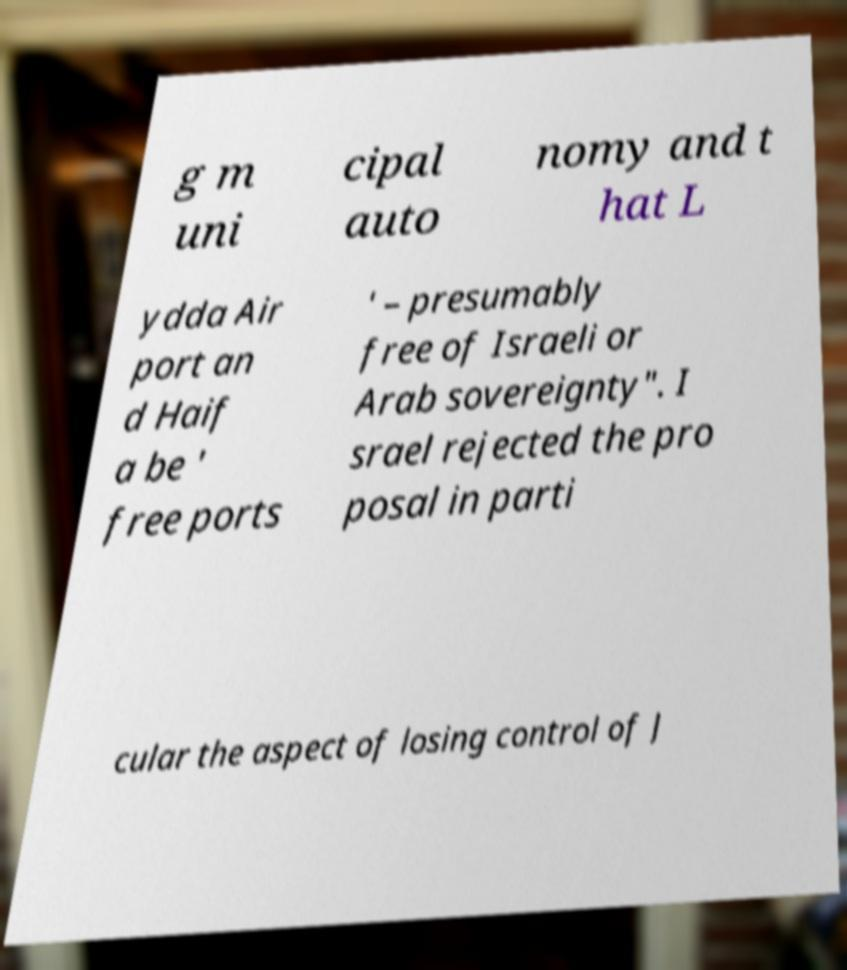Can you accurately transcribe the text from the provided image for me? g m uni cipal auto nomy and t hat L ydda Air port an d Haif a be ' free ports ' – presumably free of Israeli or Arab sovereignty". I srael rejected the pro posal in parti cular the aspect of losing control of J 